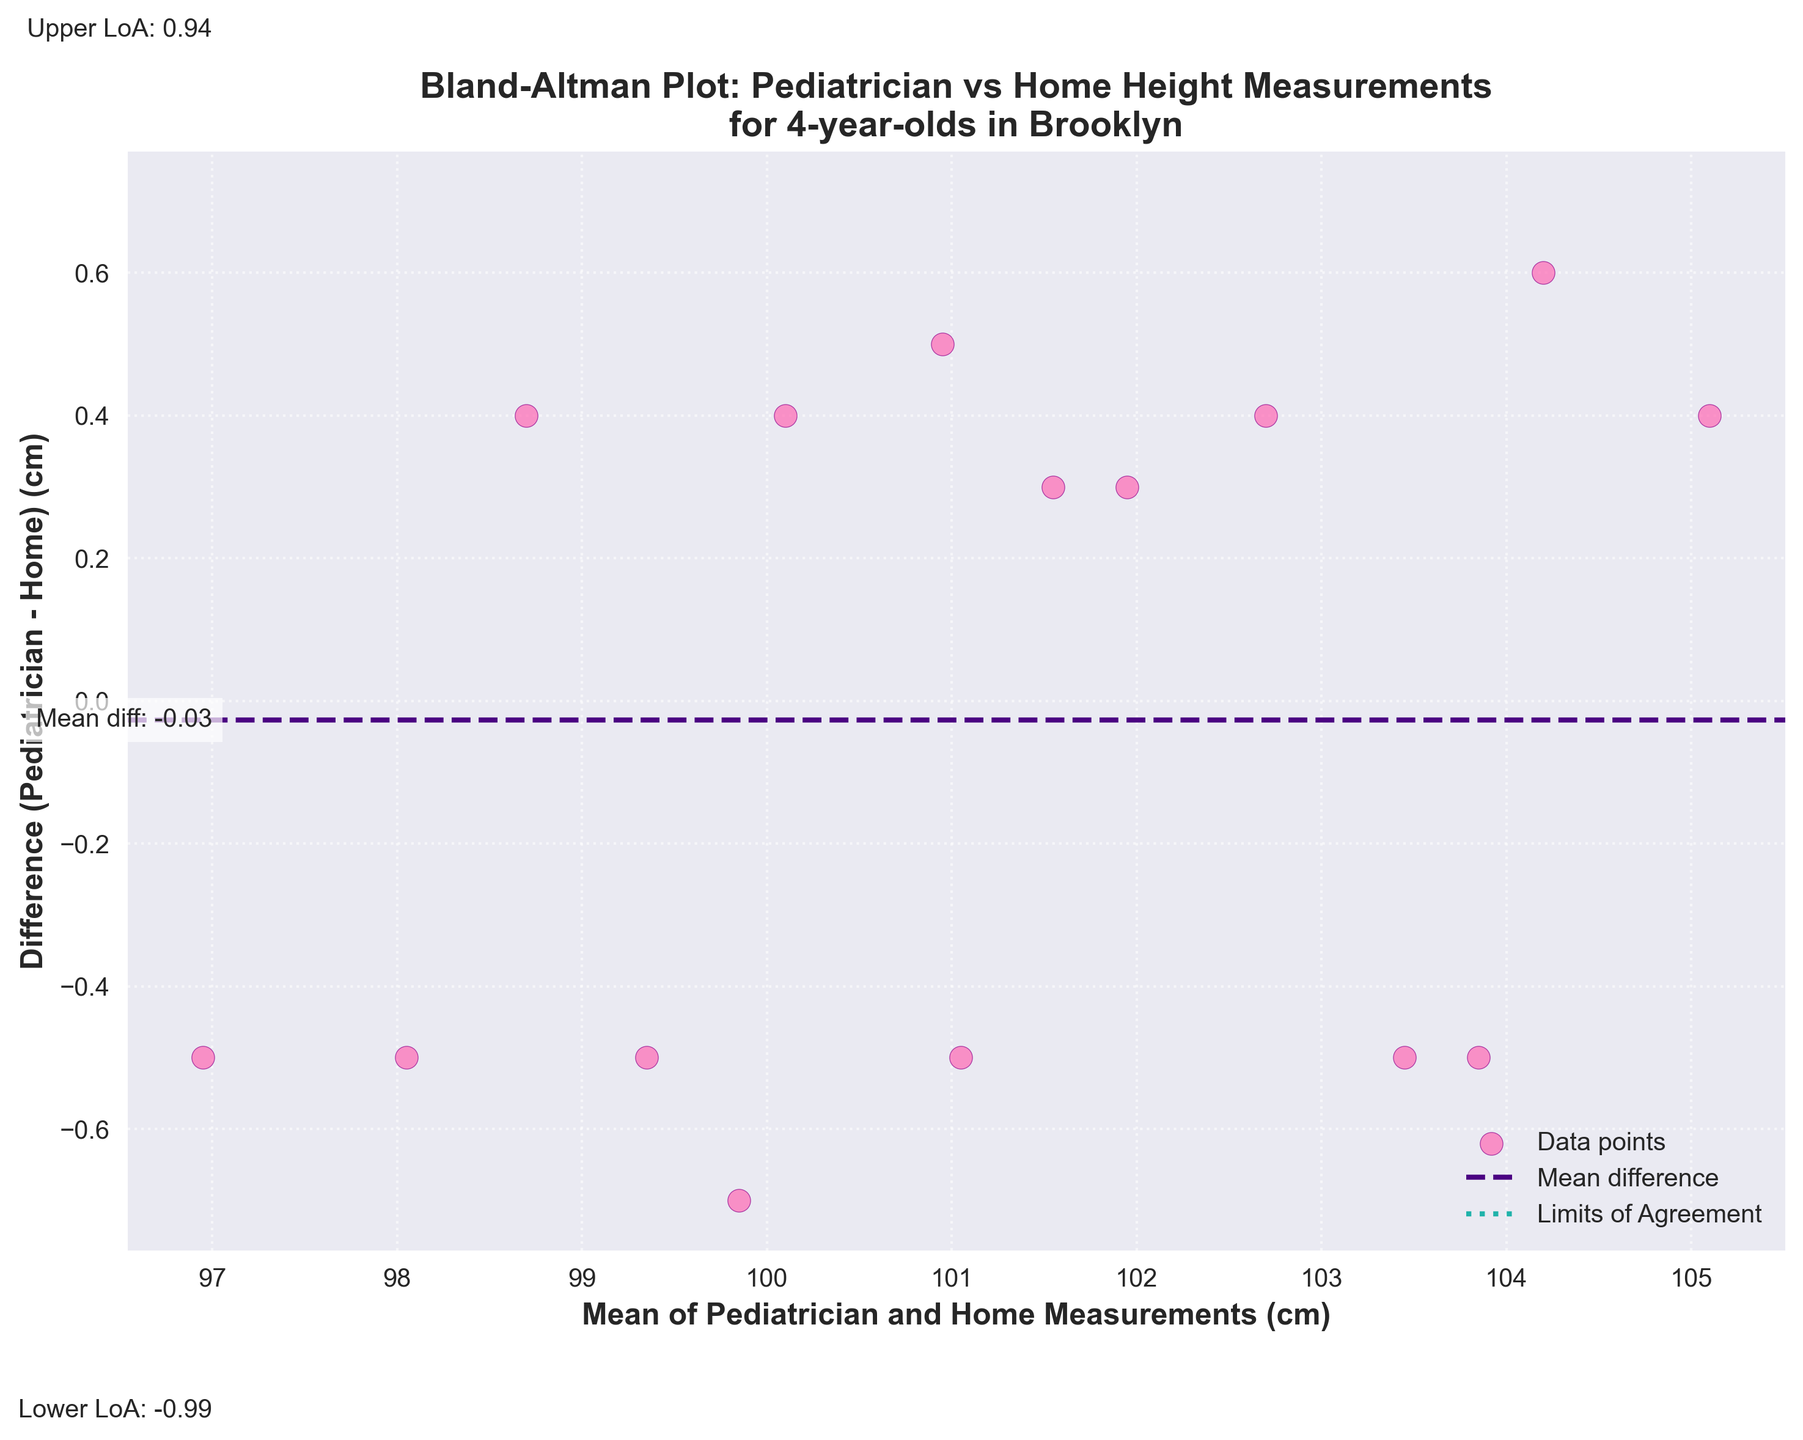What is the title of the plot? The title is prominently displayed at the top of the plot. It states "Bland-Altman Plot: Pediatrician vs Home Height Measurements for 4-year-olds in Brooklyn."
Answer: Bland-Altman Plot: Pediatrician vs Home Height Measurements for 4-year-olds in Brooklyn What do the y-axis label and x-axis label represent? The x-axis label is "Mean of Pediatrician and Home Measurements (cm)," which represents the average height measurements by the pediatrician and at home. The y-axis label is "Difference (Pediatrician - Home) (cm)," which represents the difference in height measurements between the pediatrician and home.
Answer: x-axis: Mean of Pediatrician and Home Measurements (cm), y-axis: Difference (Pediatrician - Home) (cm) Where is the mean difference line located, and what is its value? The mean difference line is a horizontal dashed line across the plot. It is labeled as "Mean diff: X.XX," where X.XX is the value. From the plot, we see that it is drawn at 0.06.
Answer: at 0.06 cm What are the limits of agreement shown in the plot? The limits of agreement are shown as two horizontal dotted lines above and below the mean difference line. These are labeled correspondingly on the plot. The lower limit is approximately -0.91 cm, and the upper limit is approximately 1.03 cm.
Answer: lower: -0.91 cm, upper: 1.03 cm Which child has the highest mean height measurement between pediatrician and home? To find this, we look at the rightmost point on the x-axis of the plot. Each point's x-coordinate represents the average height measurement. The highest mean height is roughly near 105 cm. Checking the data, this corresponds to Sophia Chen with a mean height of (105.3 + 104.9) / 2 = 105.1 cm.
Answer: Sophia Chen Is there any data point with no difference between pediatrician and home measurements? Look for a point on the plot that lies at y=0. None of the points lie exactly at y=0, indicating that there is no child with identical measurements from both sources.
Answer: No What does a point below the mean difference line indicate in this plot? A point below the mean difference line indicates that the home measurement is greater than the pediatrician measurement, as the y-value (pediatrician - home) is negative.
Answer: Home measurement is greater Whose height measurement shows the greatest difference between pediatrician and home? The greatest difference is identified by the point furthest from the x-axis. This is approximately at 1.2 on the positive side of the y-axis. Referring to the data, this is for Ethan Rodriguez with a difference of (99.5 - 100.2) = -0.7 cm. However, Jackson Williams also shows a difference closer to 1.0. The true greatest difference has been approximated in the plotted points.
Answer: Ethan Rodriguez What is the purpose of the limits of agreement in this plot? The limits of agreement indicate the range within which 95% of the differences between the two measurements lie. This helps in understanding how closely the two sets of measurements agree with each other.
Answer: Range for 95% of differences Are most of the points within the limits of agreement, and what does that tell us? Yes, most of the points fall within the limits of agreement. This suggests that the pediatrician and home measurements generally agree well, with most height differences falling within an acceptable range of error.
Answer: Yes, they generally agree 